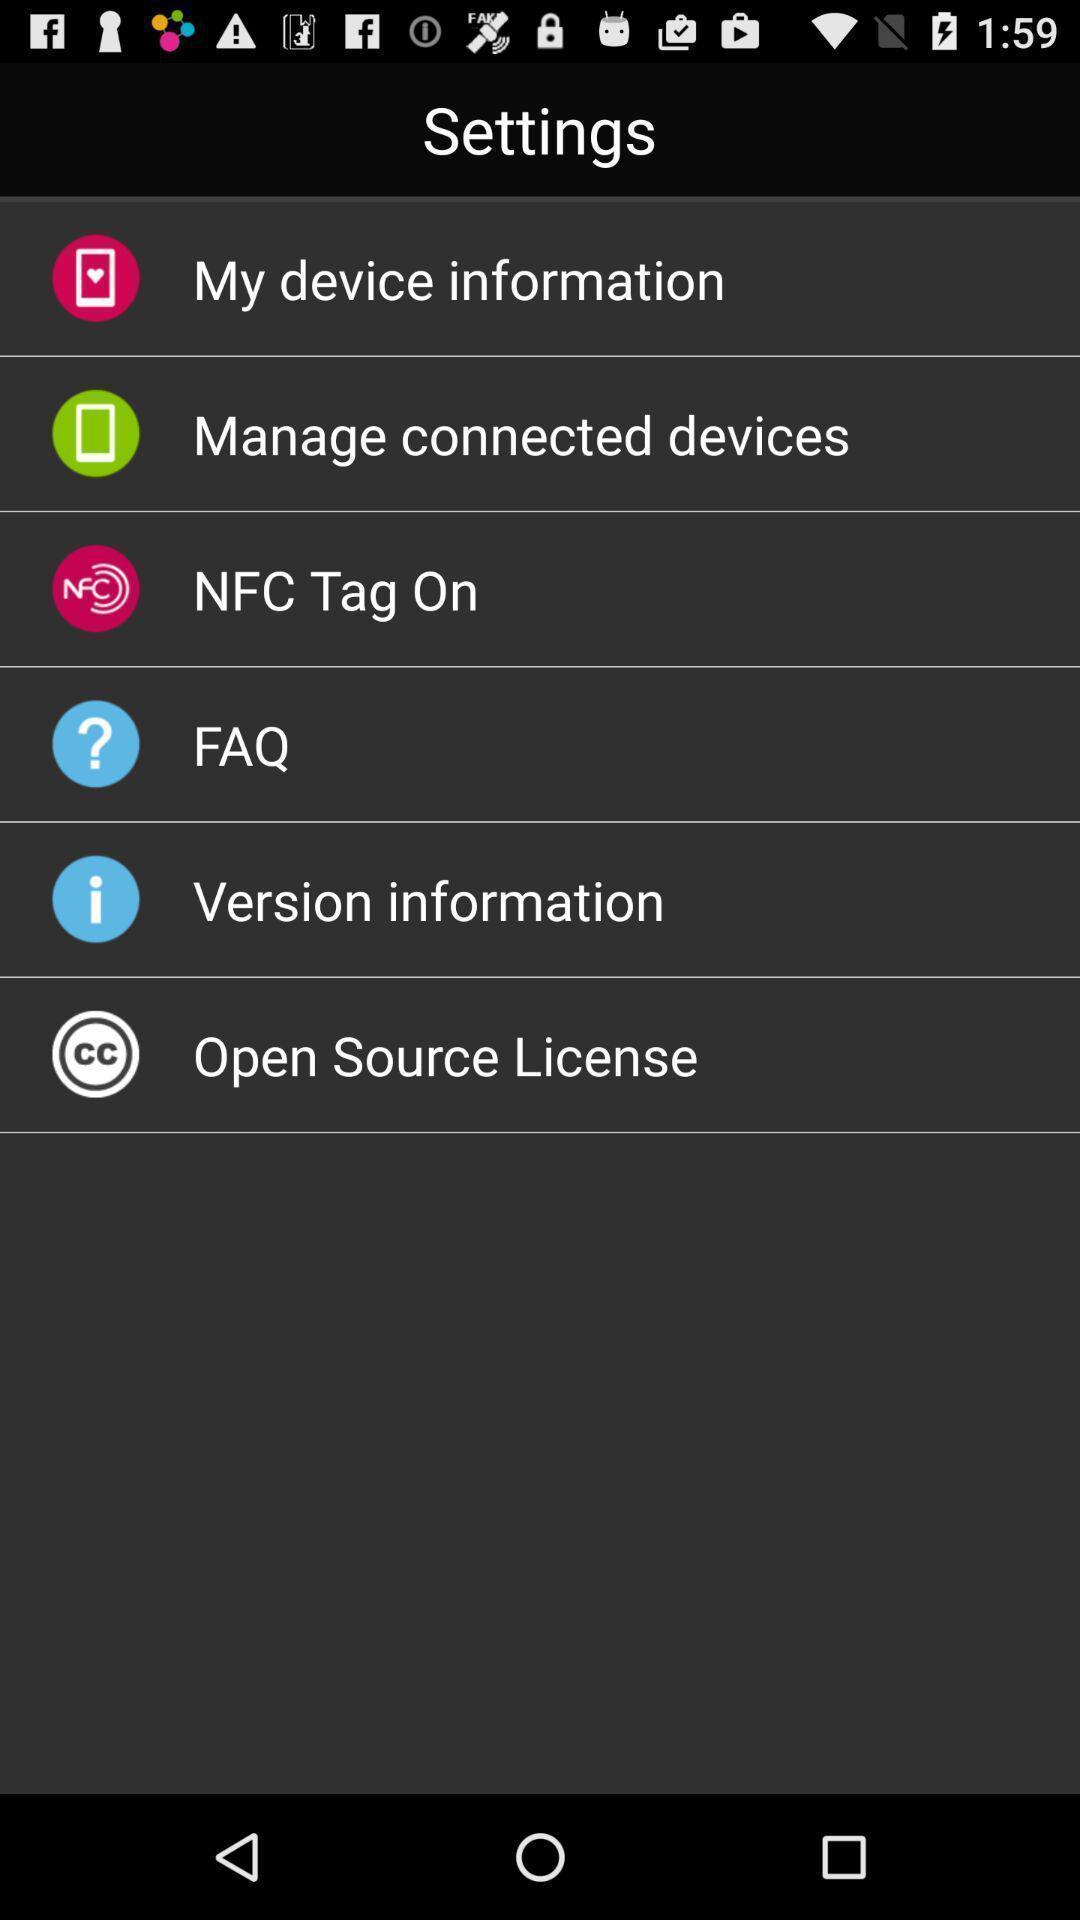Describe the key features of this screenshot. Settings options for a device. 